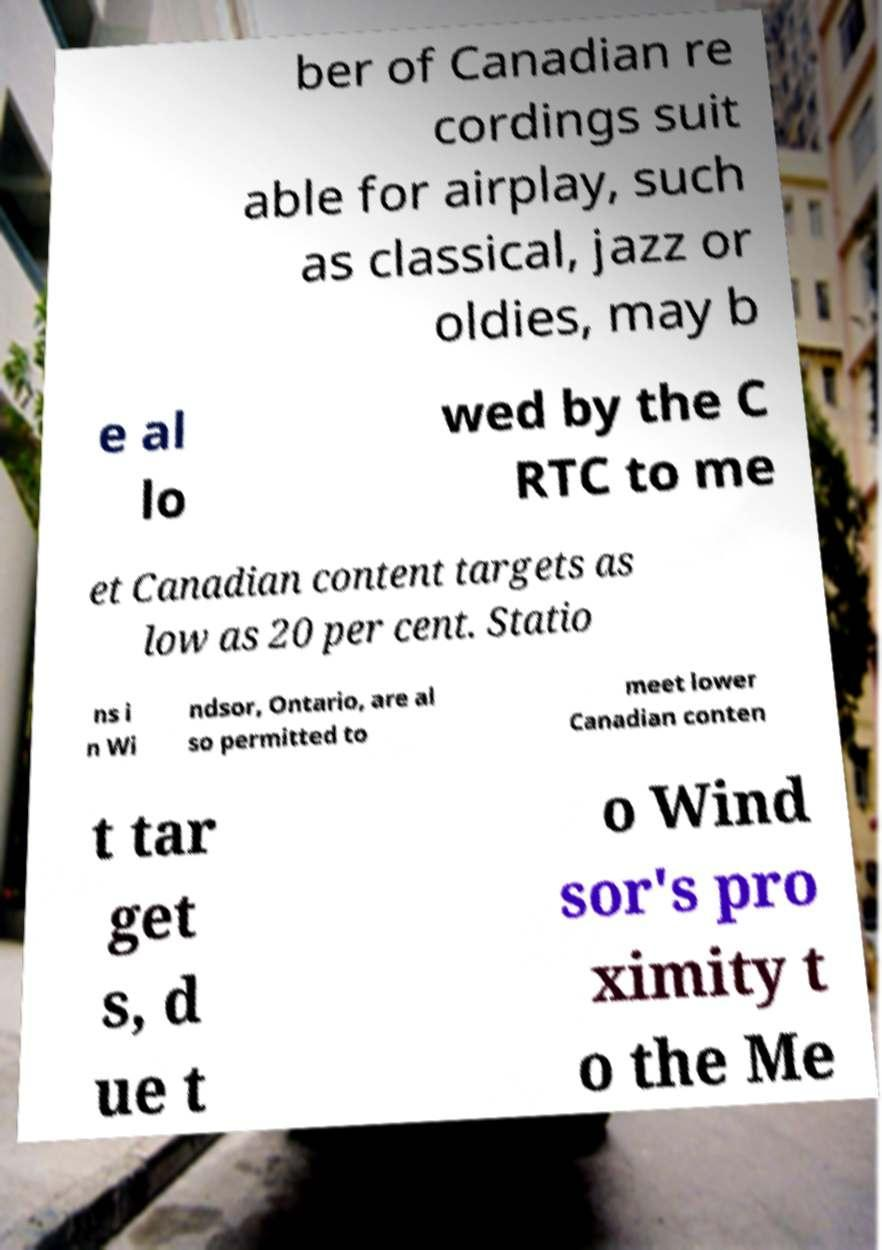For documentation purposes, I need the text within this image transcribed. Could you provide that? ber of Canadian re cordings suit able for airplay, such as classical, jazz or oldies, may b e al lo wed by the C RTC to me et Canadian content targets as low as 20 per cent. Statio ns i n Wi ndsor, Ontario, are al so permitted to meet lower Canadian conten t tar get s, d ue t o Wind sor's pro ximity t o the Me 